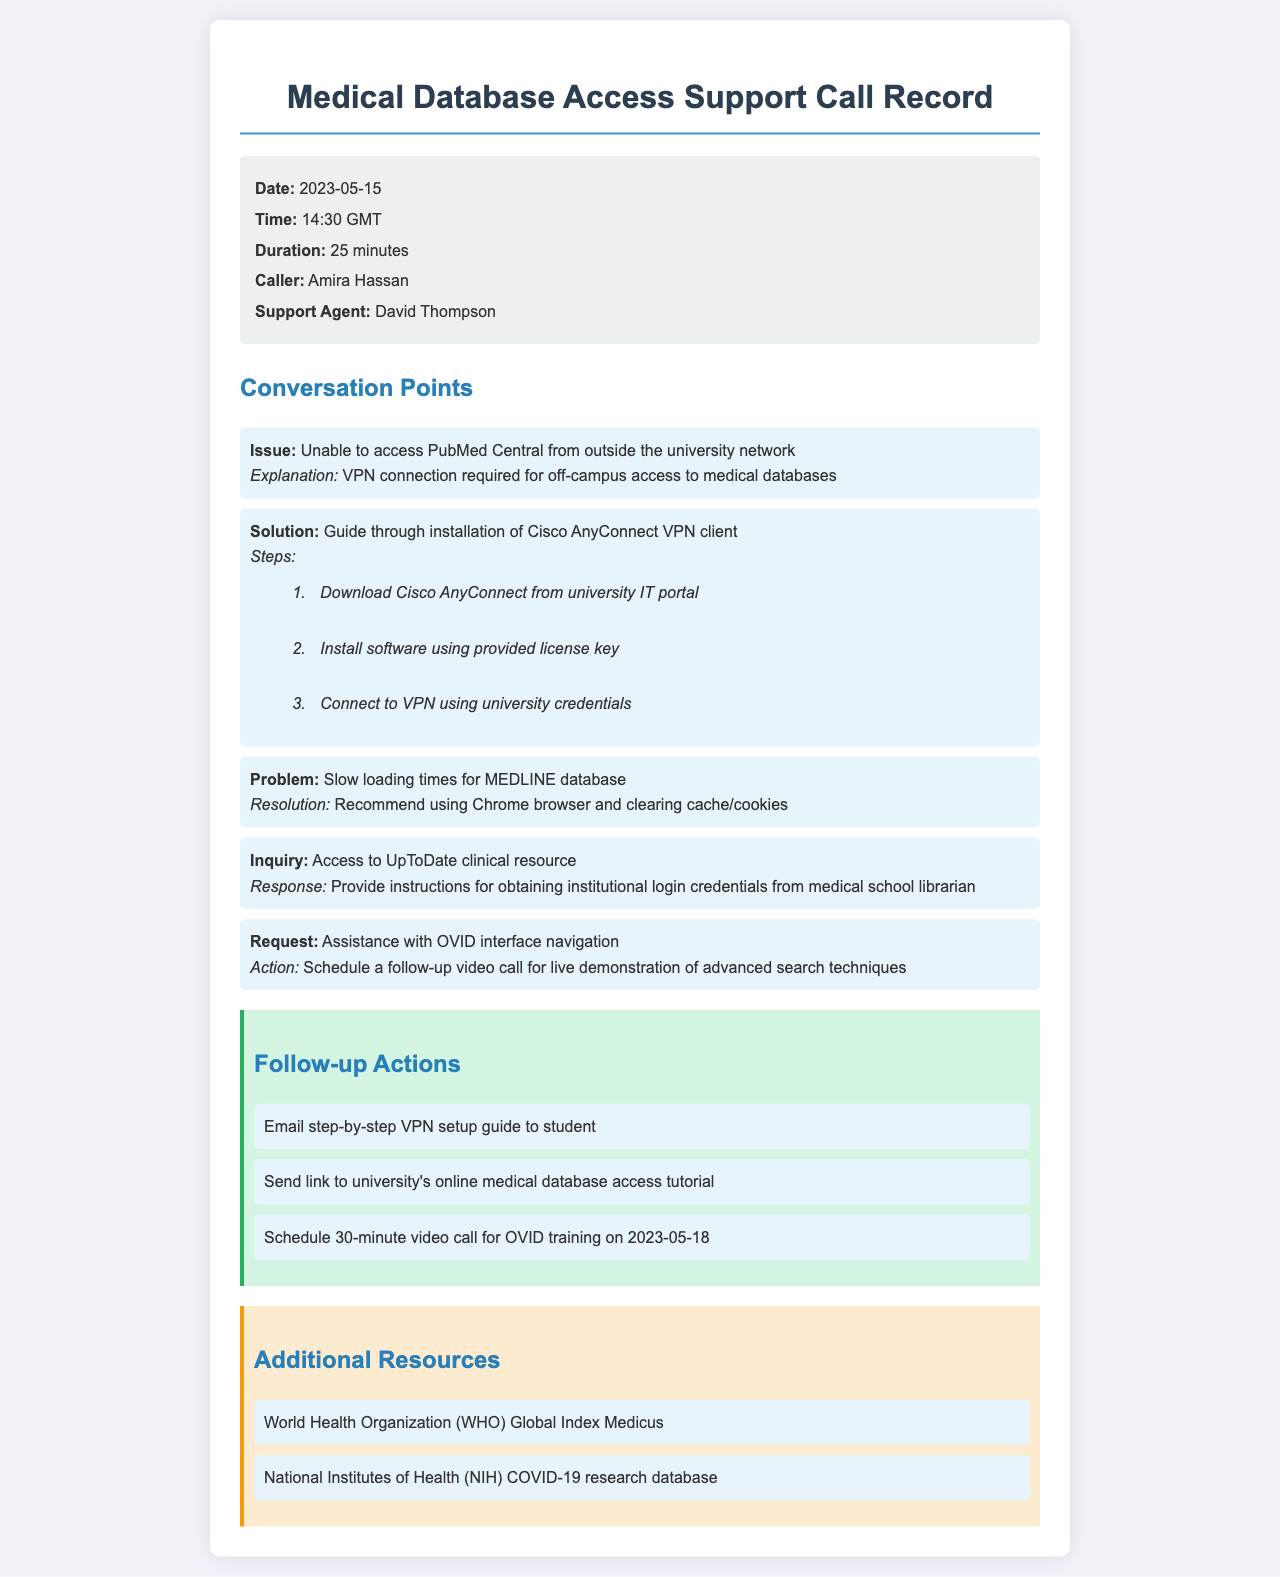what date did the phone consultation occur? The date is explicitly mentioned in the call details of the document.
Answer: 2023-05-15 who was the caller during the IT support consultation? The caller's name is listed in the call details section of the document.
Answer: Amira Hassan how long did the phone consultation last? The duration of the call is specified in the call details.
Answer: 25 minutes what issue was the caller facing while accessing the medical database? The issue regarding accessing a specific database is outlined in the conversation points.
Answer: Unable to access PubMed Central what is the recommended browser for improved loading times for the MEDLINE database? The document provides a suggestion regarding browser usage to address slow performance.
Answer: Chrome which resource provides instructions for accessing UpToDate? The response section of the inquiry explains where to obtain the necessary credentials.
Answer: Medical school librarian when was the follow-up video call for OVID training scheduled? The scheduled date for the training is noted in the follow-up actions.
Answer: 2023-05-18 what type of VPN client was discussed in the phone consultation? The document outlines the specific software required for VPN access.
Answer: Cisco AnyConnect what website offers the WHO Global Index Medicus? The additional resources section lists specific resources related to health information.
Answer: WHO Global Index Medicus 